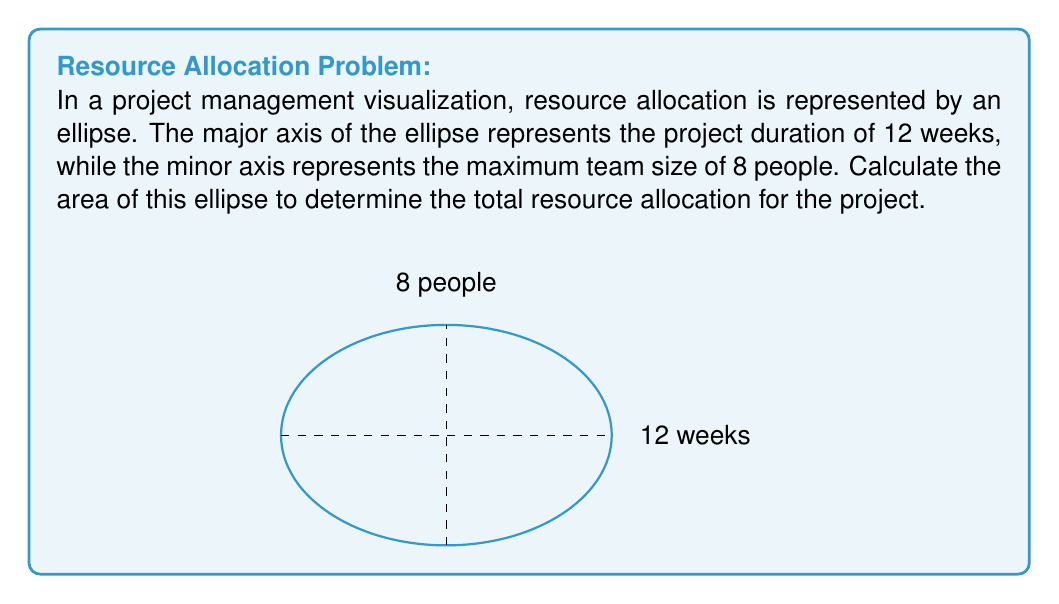Can you answer this question? To solve this problem, we'll use the formula for the area of an ellipse and follow these steps:

1) The formula for the area of an ellipse is:

   $$A = \pi ab$$

   where $a$ is half the length of the major axis and $b$ is half the length of the minor axis.

2) From the given information:
   - Major axis (project duration) = 12 weeks
   - Minor axis (max team size) = 8 people

3) Calculate $a$ and $b$:
   $a = 12/2 = 6$ weeks
   $b = 8/2 = 4$ people

4) Substitute these values into the formula:

   $$A = \pi (6)(4)$$

5) Simplify:

   $$A = 24\pi$$

6) This gives us the area in square units of weeks-people. To interpret this:
   The total resource allocation for the project is equivalent to 24π person-weeks.
Answer: $24\pi$ person-weeks 